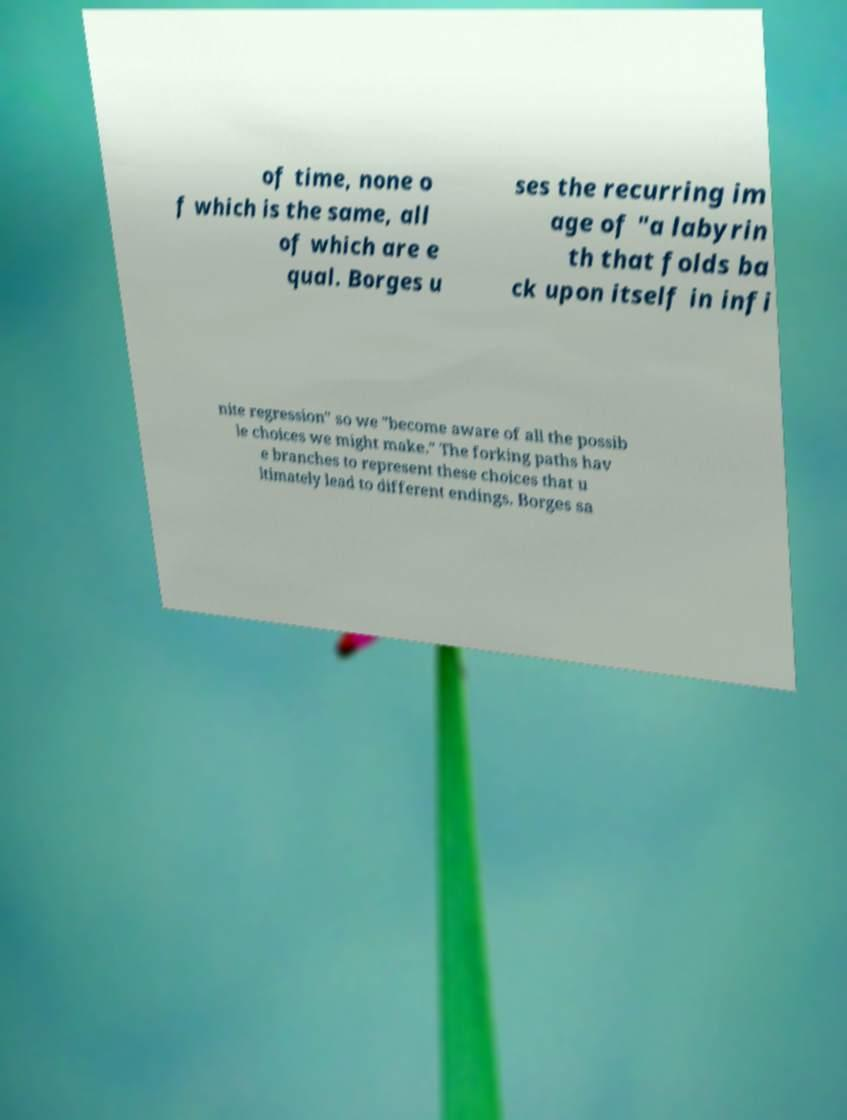Could you extract and type out the text from this image? of time, none o f which is the same, all of which are e qual. Borges u ses the recurring im age of "a labyrin th that folds ba ck upon itself in infi nite regression" so we "become aware of all the possib le choices we might make." The forking paths hav e branches to represent these choices that u ltimately lead to different endings. Borges sa 